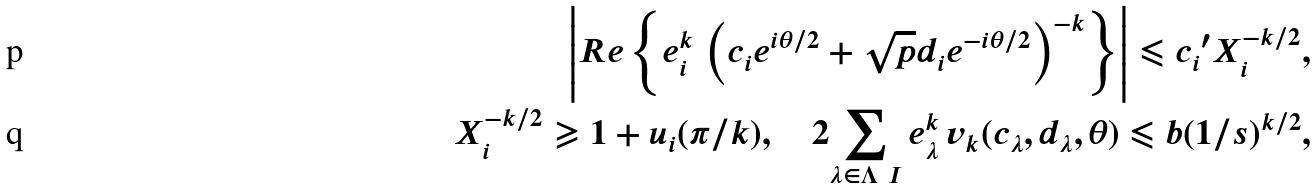<formula> <loc_0><loc_0><loc_500><loc_500>\left | R e \left \{ e _ { i } ^ { k } \, \left ( c _ { i } e ^ { i \theta / 2 } + \sqrt { p } d _ { i } e ^ { - i \theta / 2 } \right ) ^ { - k } \right \} \right | \leqslant { c _ { i } } ^ { \prime } X _ { i } ^ { - k / 2 } , \\ X _ { i } ^ { - k / 2 } \geqslant 1 + u _ { i } ( \pi / k ) , \quad 2 { \sum _ { \lambda \in \Lambda \ I } } \, e _ { \lambda } ^ { k } \, v _ { k } ( c _ { \lambda } , d _ { \lambda } , \theta ) \leqslant b ( 1 / s ) ^ { k / 2 } ,</formula> 